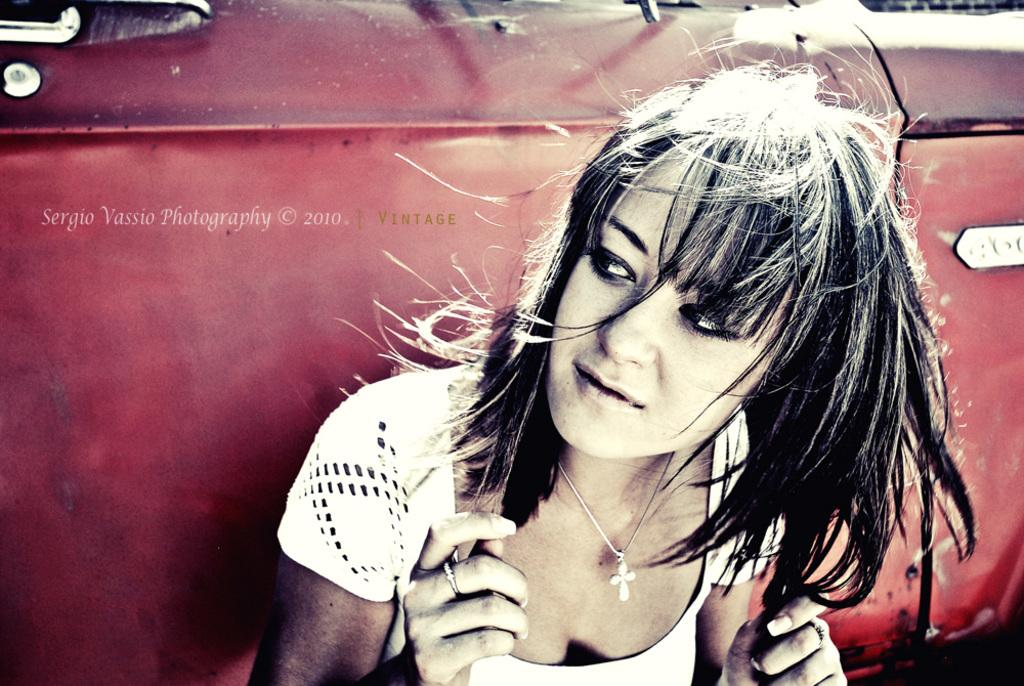Who is present in the image? There is a woman in the image. What type of vehicle can be seen in the image? There is a red car in the image. Where is the car located in the image? The car is visible in the background. What is present in the top left corner of the image? There is a watermark in the top left corner of the image. How many chairs are visible in the image? There are no chairs visible in the image. What season is depicted in the image? The season cannot be determined from the image, as there are no seasonal cues present. 